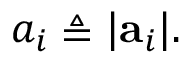Convert formula to latex. <formula><loc_0><loc_0><loc_500><loc_500>a _ { i } \triangle q | a _ { i } | .</formula> 